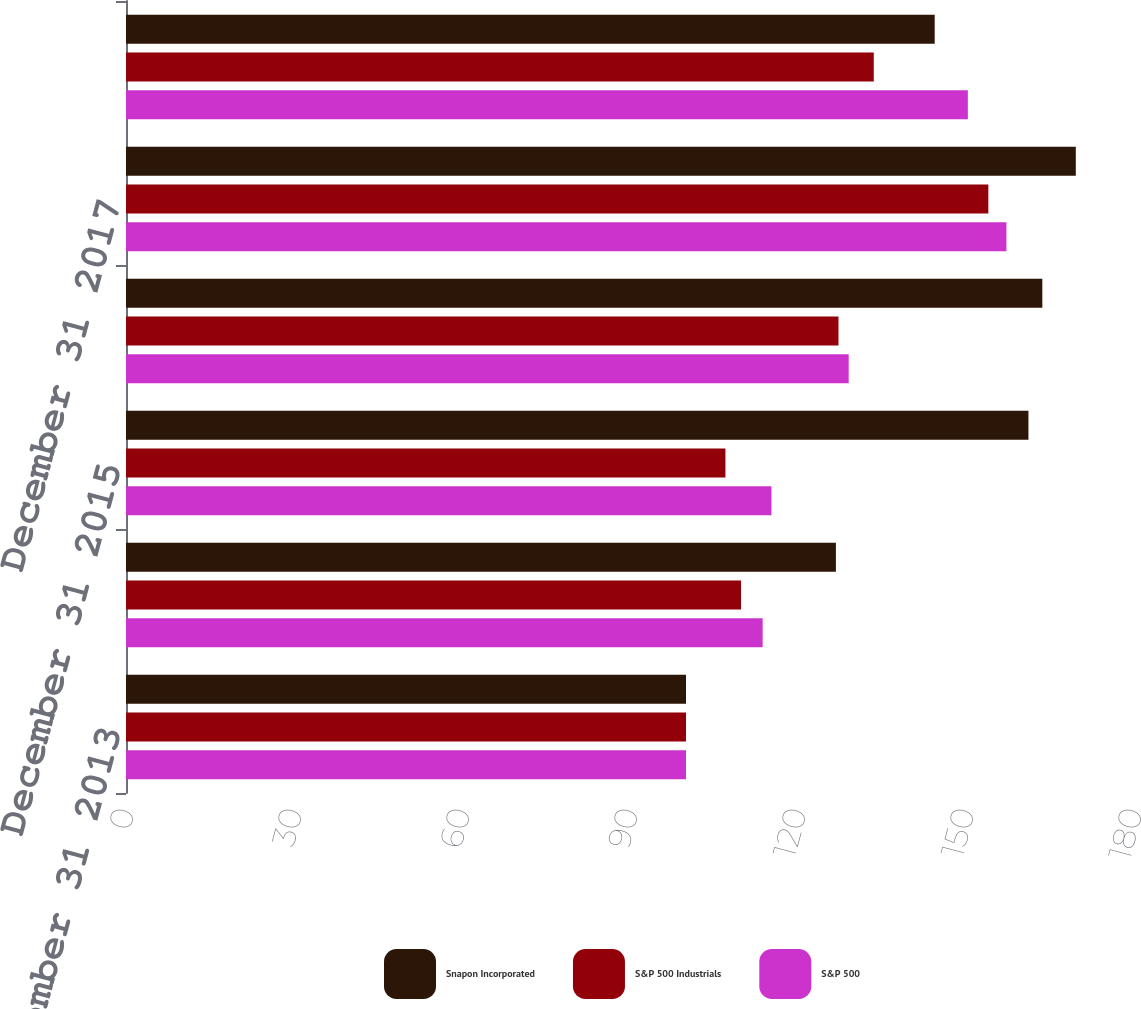<chart> <loc_0><loc_0><loc_500><loc_500><stacked_bar_chart><ecel><fcel>December 31 2013<fcel>December 31 2014<fcel>December 31 2015<fcel>December 31 2016<fcel>December 31 2017<fcel>December 31 2018<nl><fcel>Snapon Incorporated<fcel>100<fcel>126.77<fcel>161.15<fcel>163.63<fcel>169.61<fcel>144.41<nl><fcel>S&P 500 Industrials<fcel>100<fcel>109.83<fcel>107.04<fcel>127.23<fcel>153.99<fcel>133.53<nl><fcel>S&P 500<fcel>100<fcel>113.69<fcel>115.26<fcel>129.05<fcel>157.22<fcel>150.33<nl></chart> 